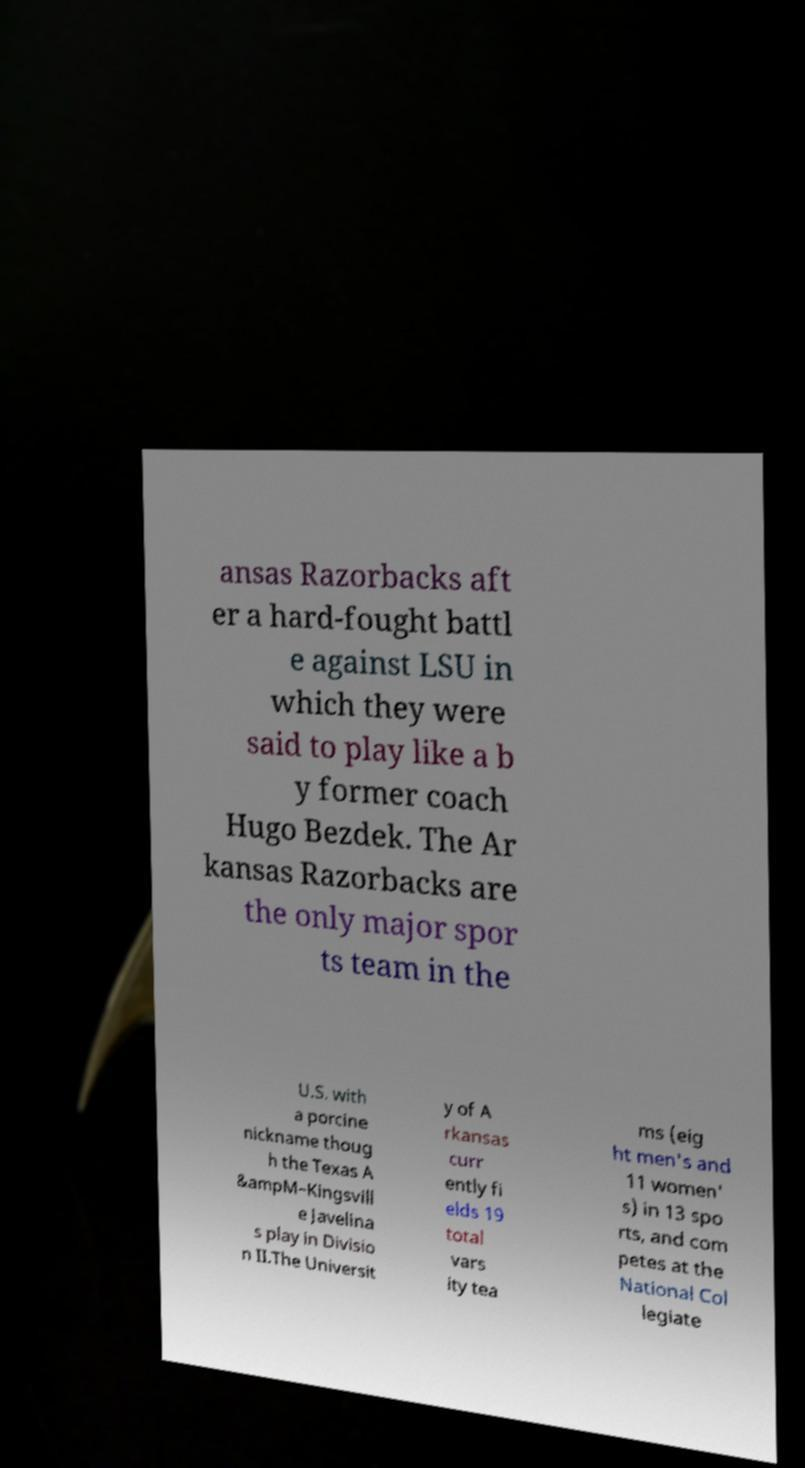Could you extract and type out the text from this image? ansas Razorbacks aft er a hard-fought battl e against LSU in which they were said to play like a b y former coach Hugo Bezdek. The Ar kansas Razorbacks are the only major spor ts team in the U.S. with a porcine nickname thoug h the Texas A &ampM–Kingsvill e Javelina s play in Divisio n II.The Universit y of A rkansas curr ently fi elds 19 total vars ity tea ms (eig ht men's and 11 women' s) in 13 spo rts, and com petes at the National Col legiate 